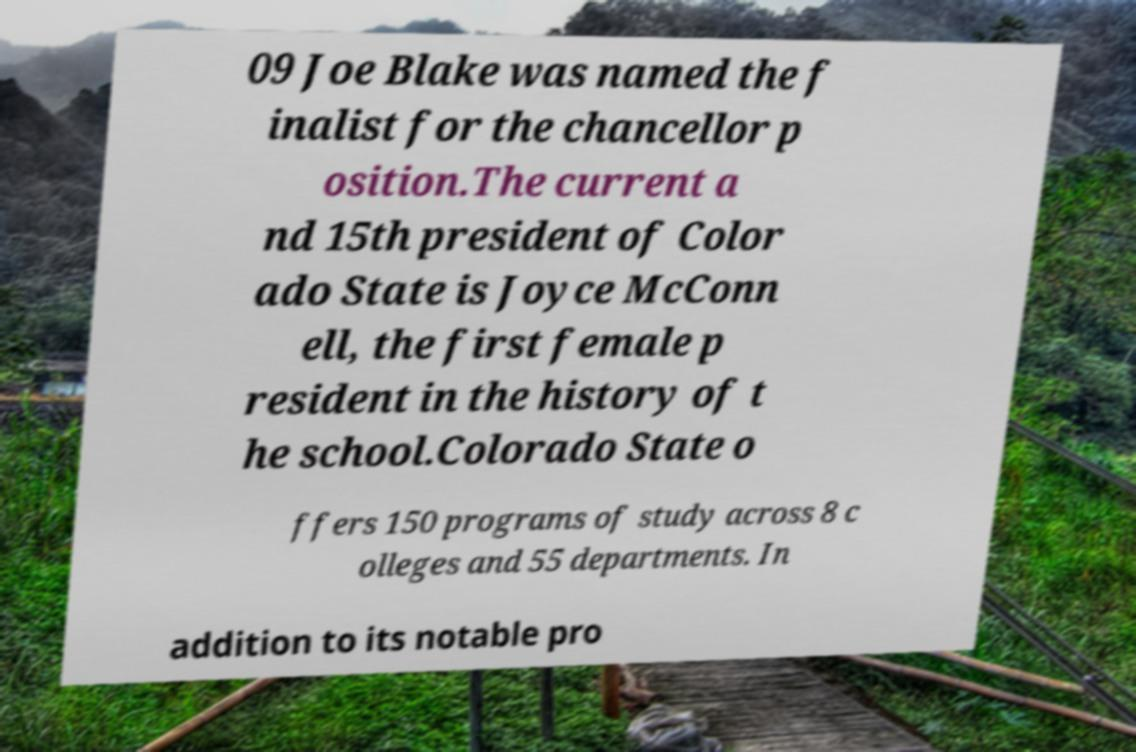Can you read and provide the text displayed in the image?This photo seems to have some interesting text. Can you extract and type it out for me? 09 Joe Blake was named the f inalist for the chancellor p osition.The current a nd 15th president of Color ado State is Joyce McConn ell, the first female p resident in the history of t he school.Colorado State o ffers 150 programs of study across 8 c olleges and 55 departments. In addition to its notable pro 